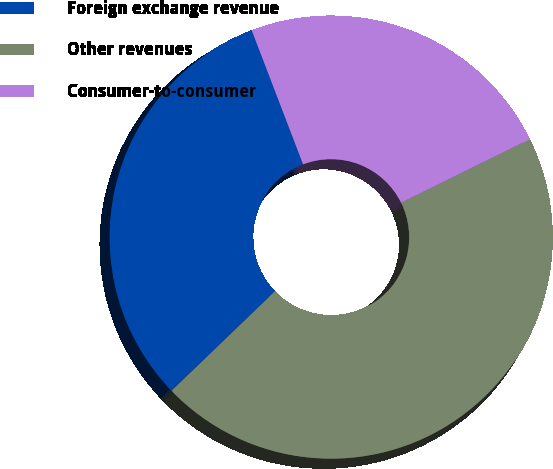Convert chart. <chart><loc_0><loc_0><loc_500><loc_500><pie_chart><fcel>Foreign exchange revenue<fcel>Other revenues<fcel>Consumer-to-consumer<nl><fcel>31.37%<fcel>45.1%<fcel>23.53%<nl></chart> 